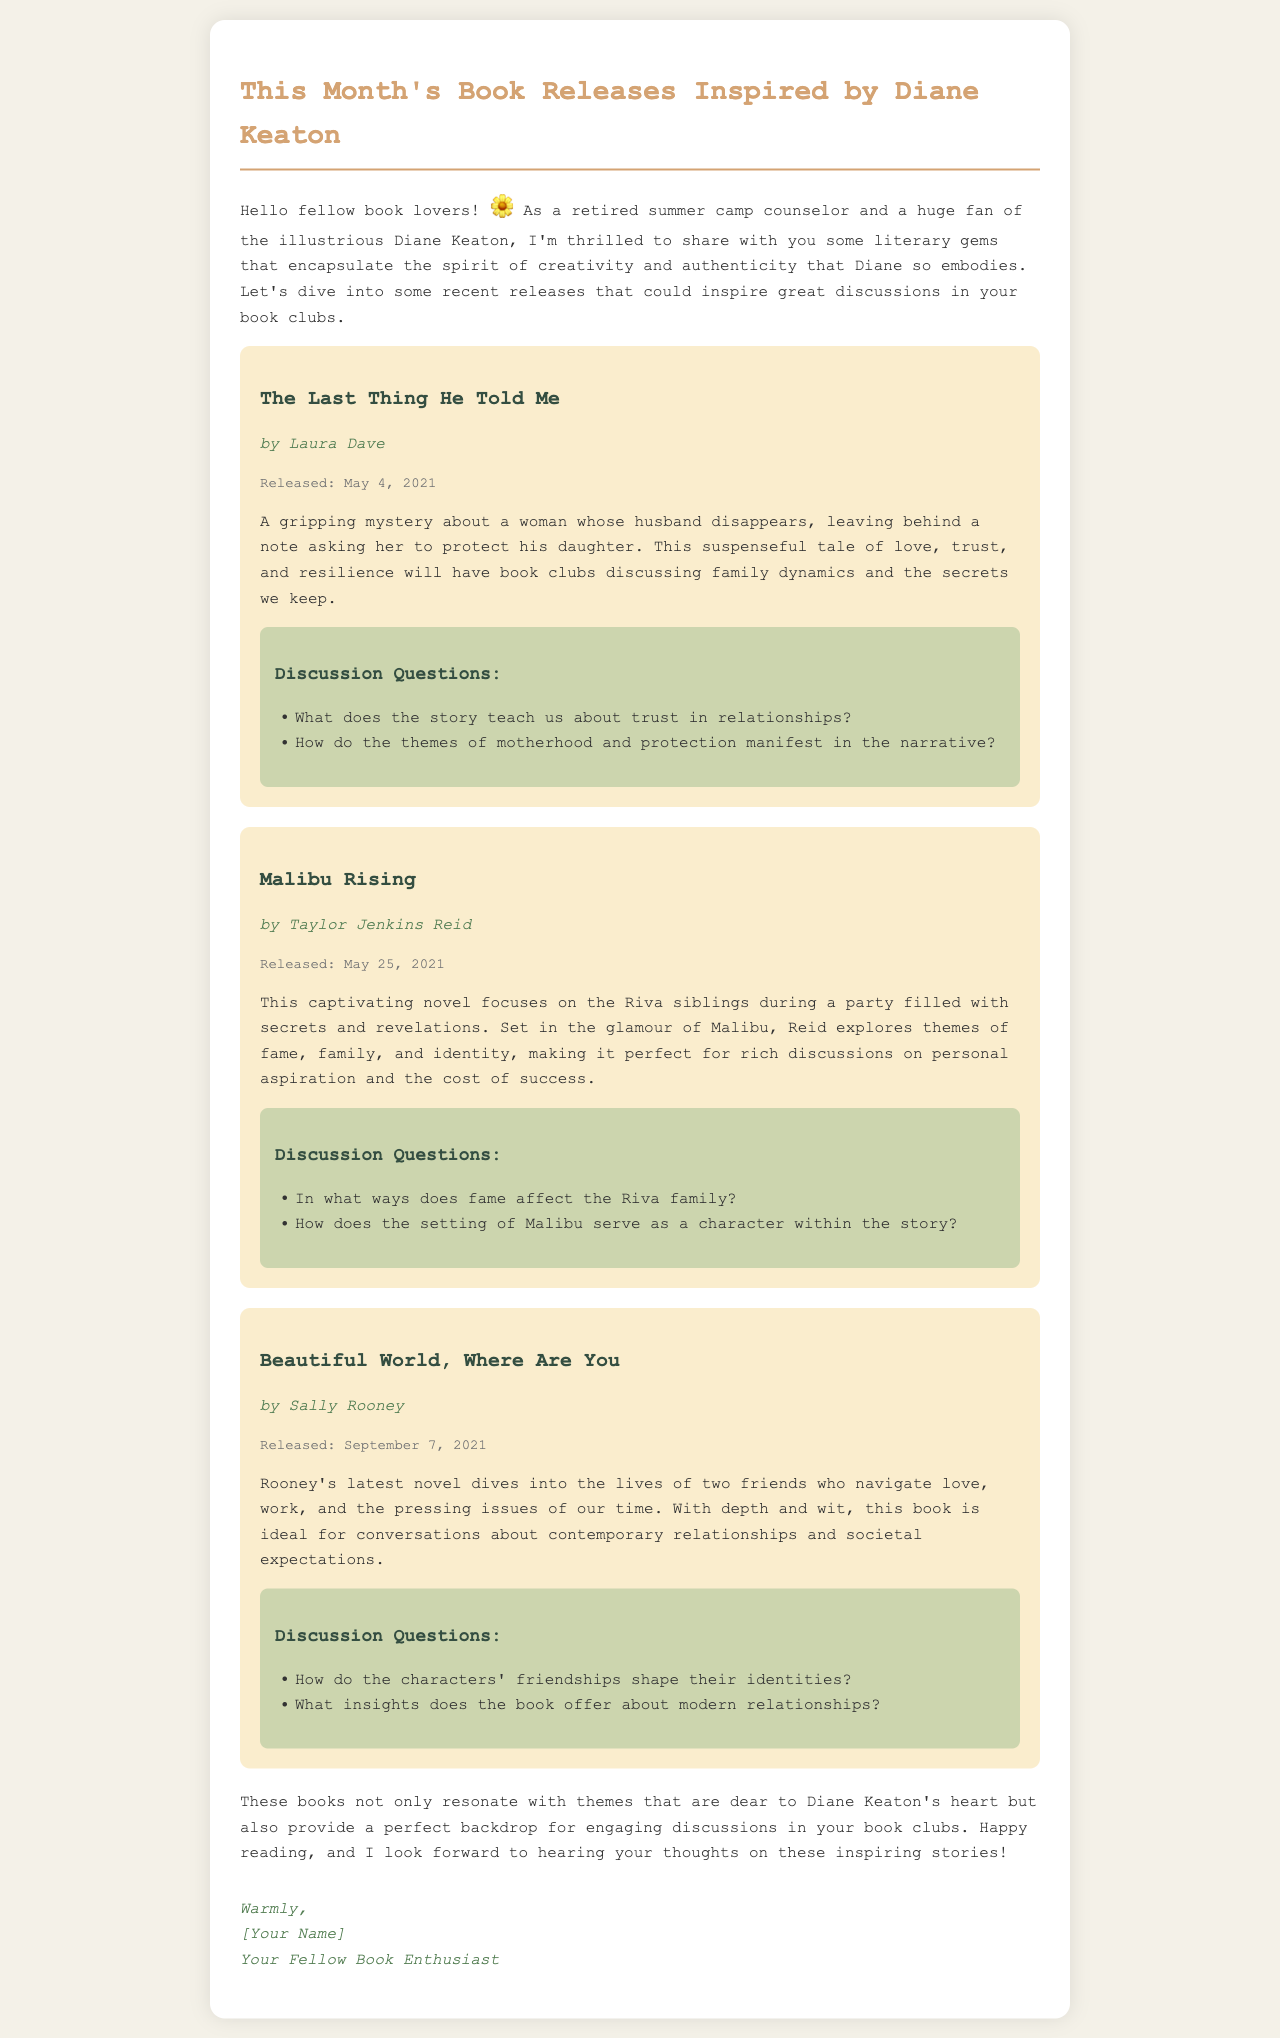What is the title of the newsletter? The title of the newsletter is presented prominently at the beginning of the document.
Answer: This Month's Book Releases Inspired by Diane Keaton Who is the author of "Malibu Rising"? The author's name is listed under the title of the book in the document.
Answer: Taylor Jenkins Reid When was "The Last Thing He Told Me" released? The release date is specified for each book in the newsletter.
Answer: May 4, 2021 What theme does "Beautiful World, Where Are You" explore? The book summary provides insights into the central themes of the book.
Answer: Contemporary relationships What are the discussion questions for "Malibu Rising"? The document lists specific questions for each book's discussion section.
Answer: In what ways does fame affect the Riva family? How does the setting of Malibu serve as a character within the story? What type of document is this? The context and structure of the content indicate the type of document it is.
Answer: Newsletter How many books are highlighted in the document? The number of book sections provides this information directly from the document.
Answer: Three What is the signature of the newsletter? The signature is presented at the end of the newsletter, indicating the sender's warmth.
Answer: Warmly, [Your Name] Your Fellow Book Enthusiast What is the main audience for this newsletter? The initial greeting and tone of the email indicate its primary audience.
Answer: Book lovers 